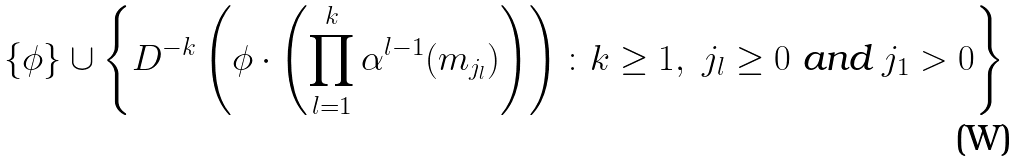<formula> <loc_0><loc_0><loc_500><loc_500>\{ \phi \} \cup \left \{ D ^ { - k } \left ( \phi \cdot \left ( \prod _ { l = 1 } ^ { k } \alpha ^ { l - 1 } ( m _ { j _ { l } } ) \right ) \right ) \colon k \geq 1 , \ j _ { l } \geq 0 \text { and } j _ { 1 } > 0 \right \}</formula> 